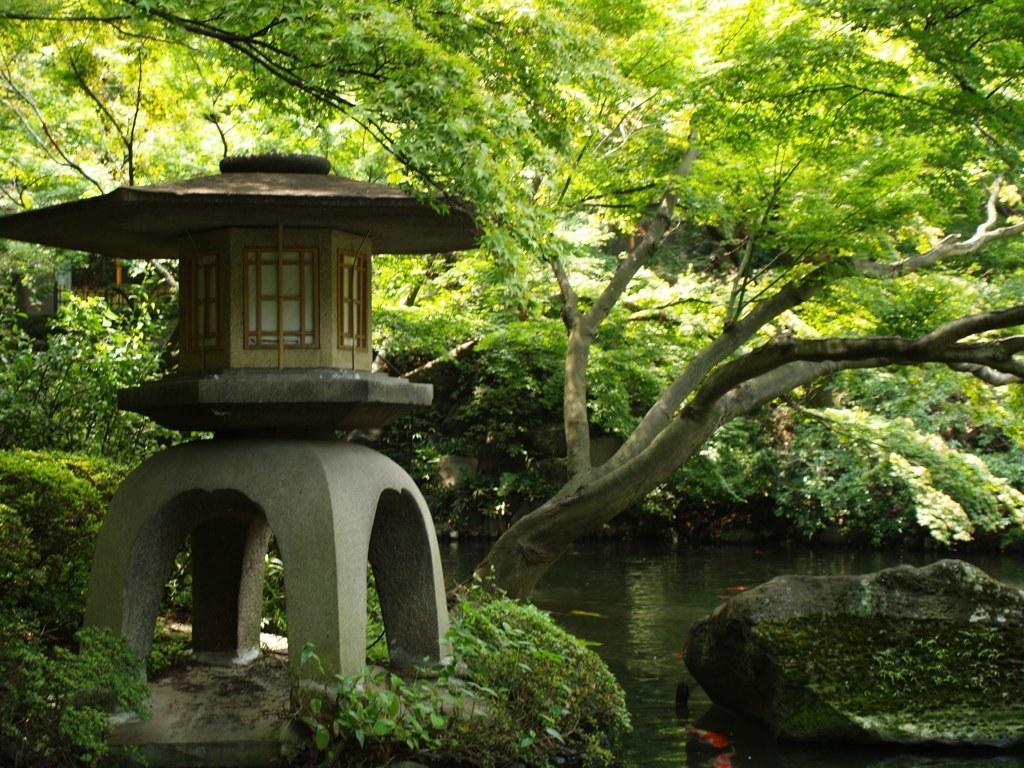Could you give a brief overview of what you see in this image? This picture might be taken from forest. In this image, on the left side, we can see a house, pillars and a glass window. On the right side, we can see a stone which is drowning on the water. In the background, we can see some trees, plants. At the bottom, we can see a land and a water in a lake 